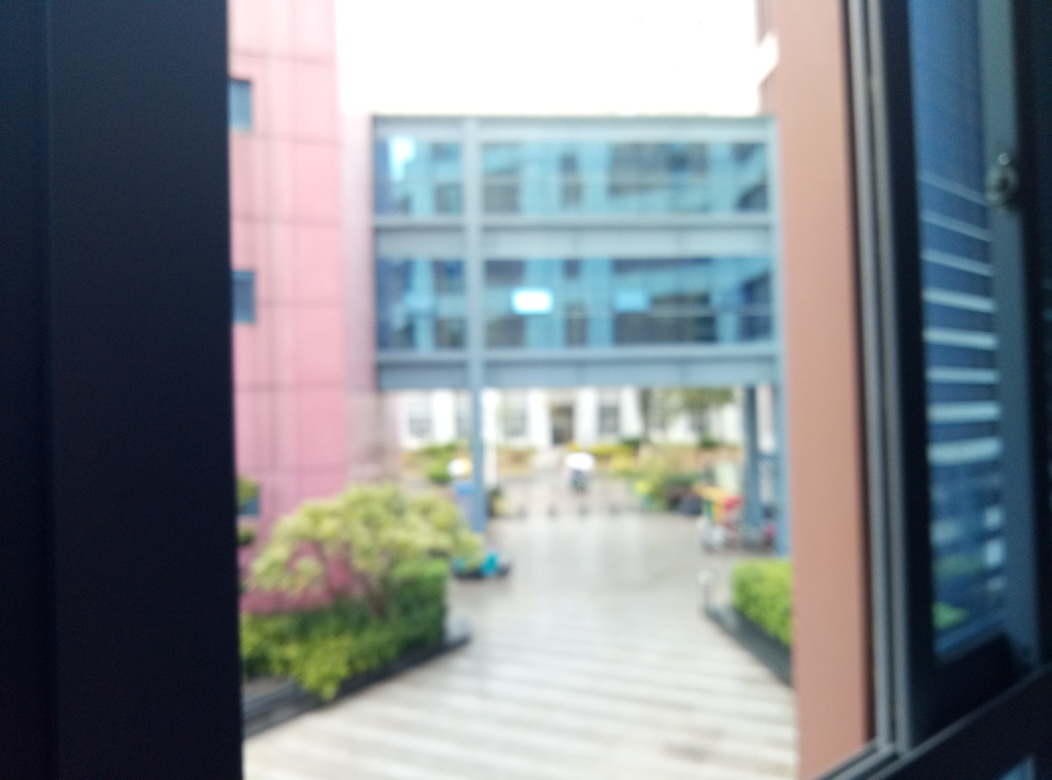What can you deduce about the place shown in this image? This image depicts a modern urban environment, possibly a courtyard or plaza nested between office buildings. The presence of well-maintained vegetation and organized walking paths suggests it's a planned space, likely designed for the enjoyment of employees or the public. The architecture style of the buildings and the open space layout indicate a contemporary design. Is there any indication of human presence or activity in this area? Although the image is blurred, you can notice some figures that appear to be people in the middle distance, by the planters. This suggests some level of human activity, though the exact nature of the activity cannot be determined from this image alone. It's likely a space used for walking, sitting, or possibly socializing during breaks from work or daily activities. 